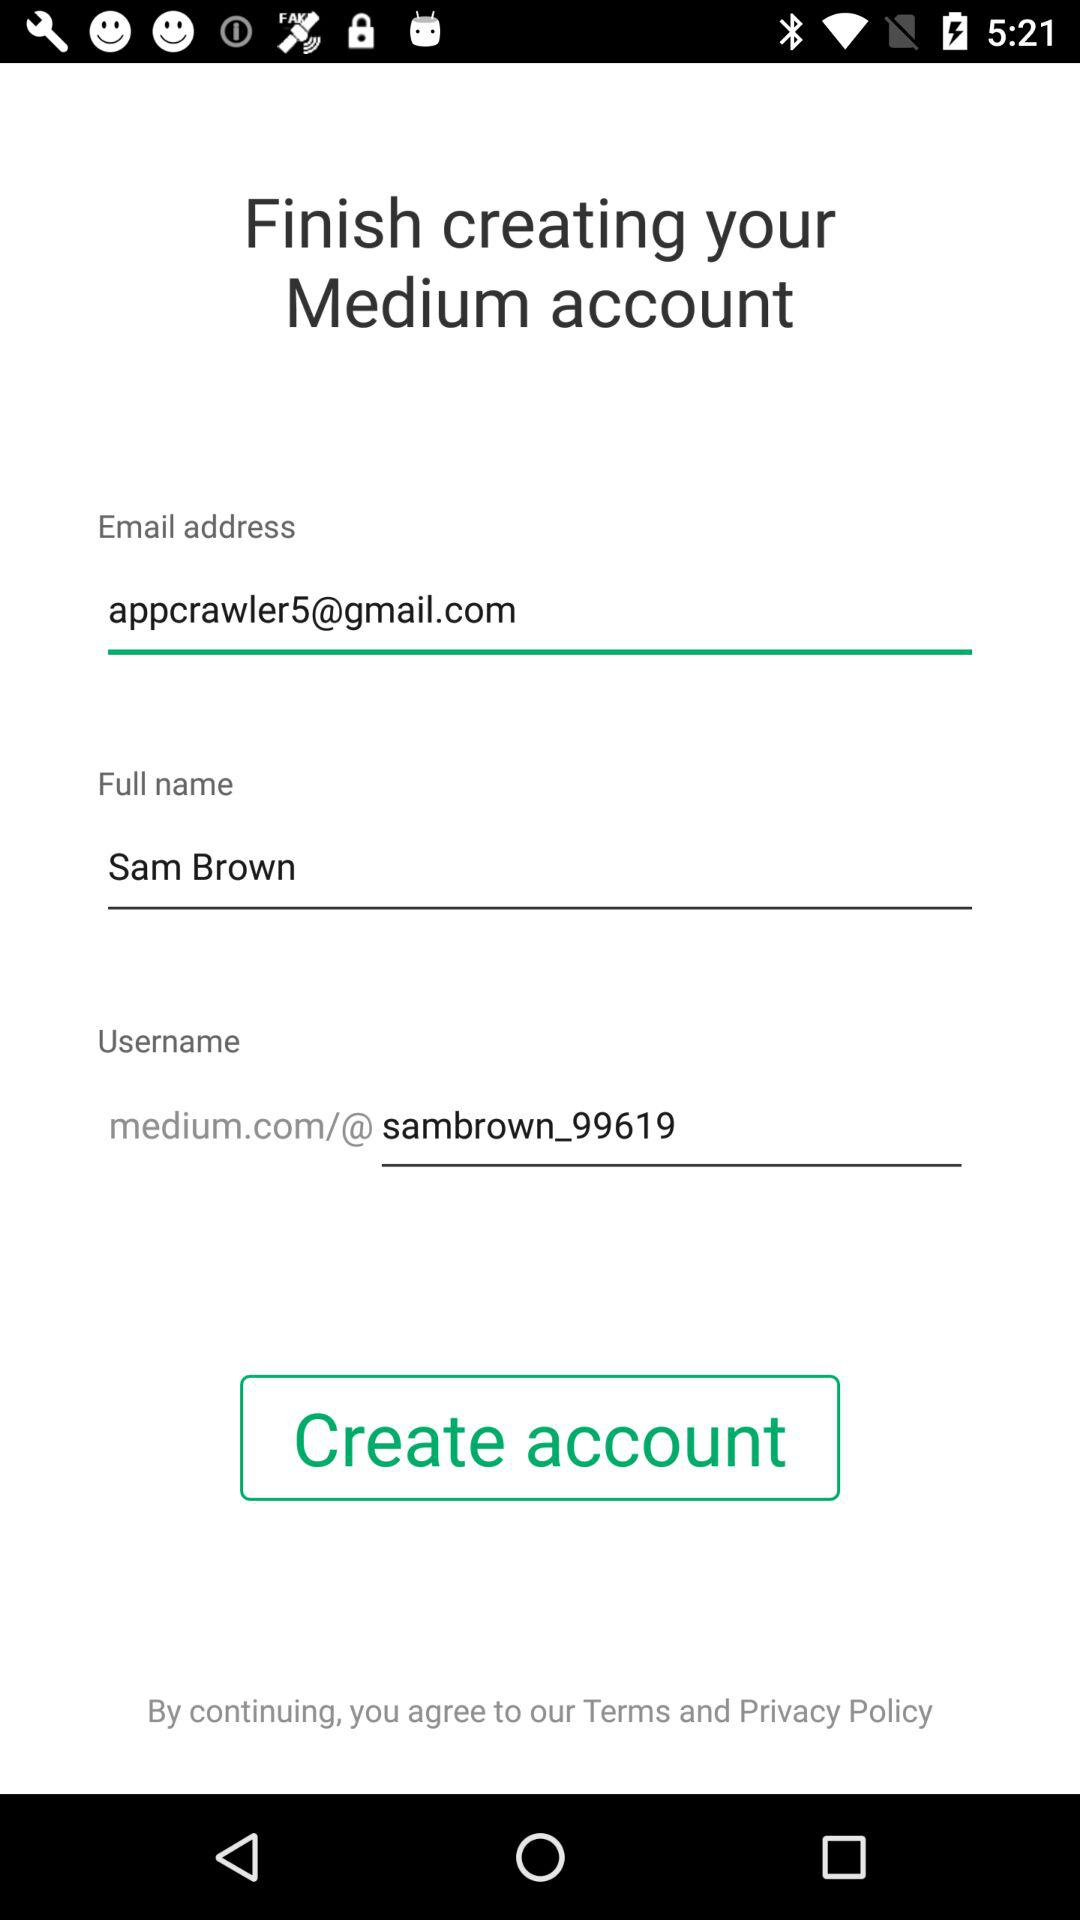What is the user name? The user name is Sam Brown. 